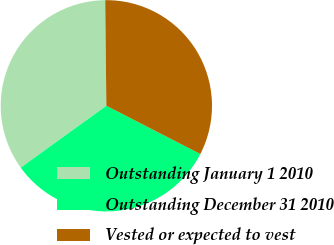Convert chart to OTSL. <chart><loc_0><loc_0><loc_500><loc_500><pie_chart><fcel>Outstanding January 1 2010<fcel>Outstanding December 31 2010<fcel>Vested or expected to vest<nl><fcel>34.79%<fcel>32.49%<fcel>32.72%<nl></chart> 